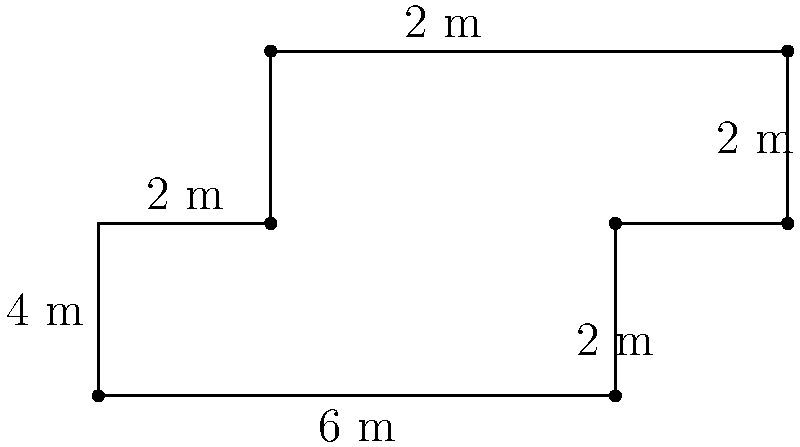In your pharmaceutical research laboratory, you need to calculate the perimeter of an irregularly shaped laboratory bench to determine the required length of a protective edge strip. The bench has the dimensions shown in the diagram above (in meters). What is the perimeter of the laboratory bench? To find the perimeter of the irregularly shaped laboratory bench, we need to sum up all the sides:

1. Start from the bottom left corner and move clockwise:
   - Bottom side: 6 m
   - Right side (first part): 2 m
   - Right side (second part): 2 m
   - Top side (right part): 2 m
   - Left side (top part): 6 m
   - Left side (bottom part): 2 m

2. Sum up all these lengths:
   $$ \text{Perimeter} = 6 + 2 + 2 + 2 + 6 + 2 = 20 \text{ m} $$

3. Therefore, the perimeter of the laboratory bench is 20 meters.

This calculation ensures that you have the correct length of protective edge strip to cover the entire perimeter of the bench, which is crucial for maintaining a safe and clean laboratory environment in pharmaceutical research.
Answer: 20 m 